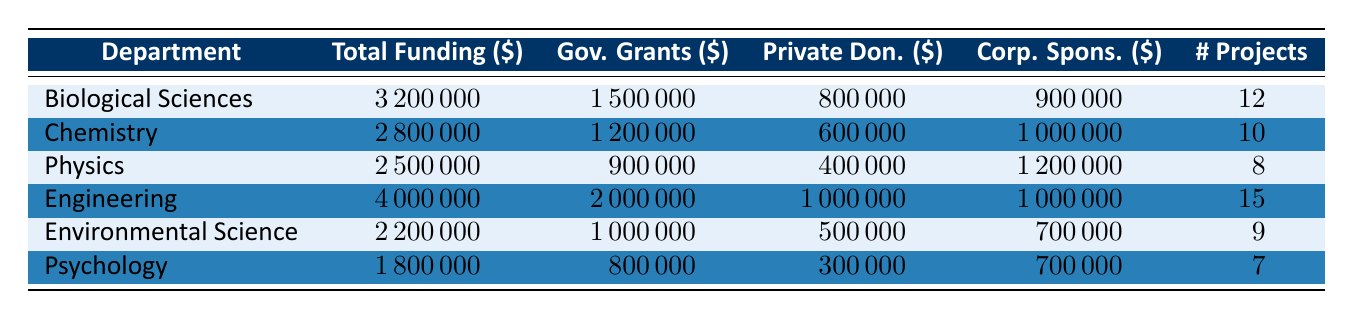What is the total funding allocated to the Engineering department? The table shows that the total funding allocated to the Engineering department is directly displayed next to its name, which is 4,000,000.
Answer: 4,000,000 Which department received the most funding from Corporate Sponsorships? By looking at the Corporate Sponsorships column, Engineering received 1,000,000, Physics received 1,200,000, Chemistry 1,000,000, Biological Sciences 900,000, Environmental Science 700,000, and Psychology 700,000. Since 1,200,000 is the highest value, Physics is the department with the most Corporate Sponsorships.
Answer: Physics How much funding did the Psychology department receive from Government Grants? The amount allocated to the Psychology department from Government Grants is listed in the table as 800,000.
Answer: 800,000 What is the total funding allocated across all departments? To find the total funding, we sum the Total Funding Allocated for each department: 3,200,000 + 2,800,000 + 2,500,000 + 4,000,000 + 2,200,000 + 1,800,000 = 16,500,000.
Answer: 16,500,000 Is the total funding for Biological Sciences higher than the combined total funding of Psychology and Environmental Science? First, we calculate the combined Total Funding for Psychology and Environmental Science: 1,800,000 + 2,200,000 = 4,000,000. Then, we compare it to Biological Sciences, which is 3,200,000. Since 3,200,000 is lower than 4,000,000, the statement is false.
Answer: No Which department has the highest number of projects, and how many project does it have? The table indicates that the Engineering department has the highest number of projects listed as 15. Other departments have fewer projects, with the next highest being Biological Sciences with 12 projects.
Answer: Engineering, 15 What percentage of the total funding for Chemistry came from Private Donations? The total funding for Chemistry is 2,800,000 and the Private Donations amount is 600,000. To find the percentage: (600,000 / 2,800,000) * 100 = 21.43 percent.
Answer: 21.43 percent What is the difference in total funding between the Biological Sciences and the Environmental Science departments? The total funding for Biological Sciences is 3,200,000 and for Environmental Science, it is 2,200,000. We subtract the Environmental Science funding from Biological Sciences funding: 3,200,000 - 2,200,000 = 1,000,000.
Answer: 1,000,000 